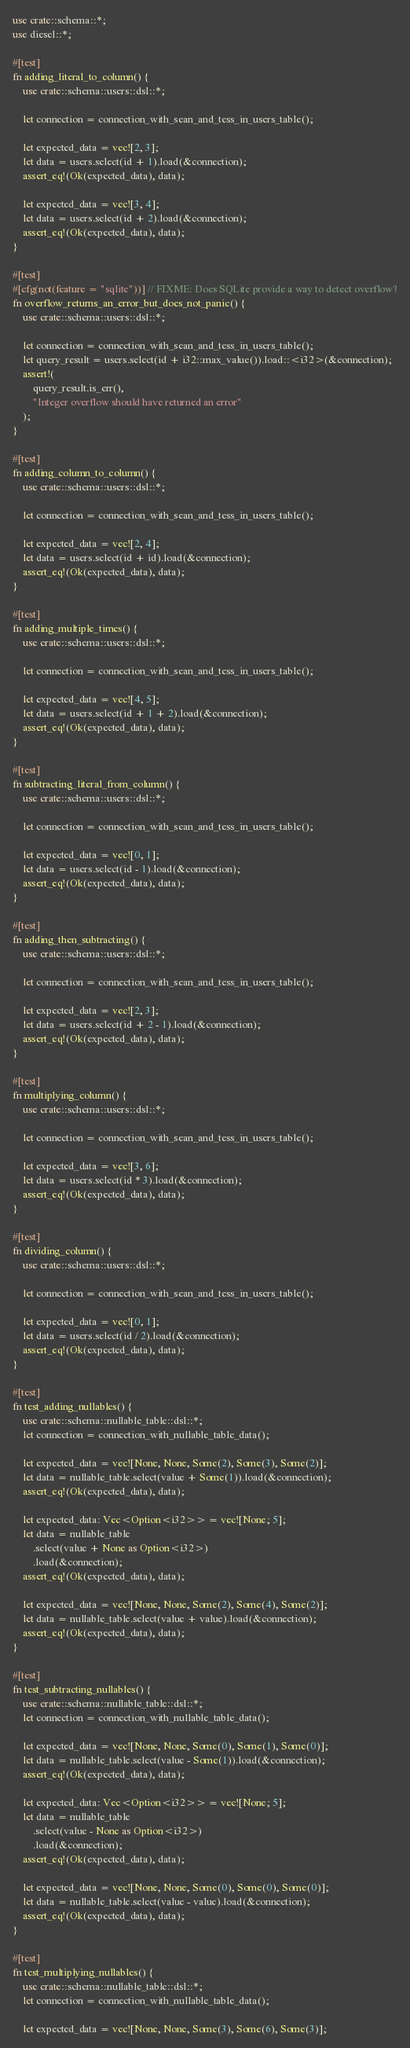<code> <loc_0><loc_0><loc_500><loc_500><_Rust_>use crate::schema::*;
use diesel::*;

#[test]
fn adding_literal_to_column() {
    use crate::schema::users::dsl::*;

    let connection = connection_with_sean_and_tess_in_users_table();

    let expected_data = vec![2, 3];
    let data = users.select(id + 1).load(&connection);
    assert_eq!(Ok(expected_data), data);

    let expected_data = vec![3, 4];
    let data = users.select(id + 2).load(&connection);
    assert_eq!(Ok(expected_data), data);
}

#[test]
#[cfg(not(feature = "sqlite"))] // FIXME: Does SQLite provide a way to detect overflow?
fn overflow_returns_an_error_but_does_not_panic() {
    use crate::schema::users::dsl::*;

    let connection = connection_with_sean_and_tess_in_users_table();
    let query_result = users.select(id + i32::max_value()).load::<i32>(&connection);
    assert!(
        query_result.is_err(),
        "Integer overflow should have returned an error"
    );
}

#[test]
fn adding_column_to_column() {
    use crate::schema::users::dsl::*;

    let connection = connection_with_sean_and_tess_in_users_table();

    let expected_data = vec![2, 4];
    let data = users.select(id + id).load(&connection);
    assert_eq!(Ok(expected_data), data);
}

#[test]
fn adding_multiple_times() {
    use crate::schema::users::dsl::*;

    let connection = connection_with_sean_and_tess_in_users_table();

    let expected_data = vec![4, 5];
    let data = users.select(id + 1 + 2).load(&connection);
    assert_eq!(Ok(expected_data), data);
}

#[test]
fn subtracting_literal_from_column() {
    use crate::schema::users::dsl::*;

    let connection = connection_with_sean_and_tess_in_users_table();

    let expected_data = vec![0, 1];
    let data = users.select(id - 1).load(&connection);
    assert_eq!(Ok(expected_data), data);
}

#[test]
fn adding_then_subtracting() {
    use crate::schema::users::dsl::*;

    let connection = connection_with_sean_and_tess_in_users_table();

    let expected_data = vec![2, 3];
    let data = users.select(id + 2 - 1).load(&connection);
    assert_eq!(Ok(expected_data), data);
}

#[test]
fn multiplying_column() {
    use crate::schema::users::dsl::*;

    let connection = connection_with_sean_and_tess_in_users_table();

    let expected_data = vec![3, 6];
    let data = users.select(id * 3).load(&connection);
    assert_eq!(Ok(expected_data), data);
}

#[test]
fn dividing_column() {
    use crate::schema::users::dsl::*;

    let connection = connection_with_sean_and_tess_in_users_table();

    let expected_data = vec![0, 1];
    let data = users.select(id / 2).load(&connection);
    assert_eq!(Ok(expected_data), data);
}

#[test]
fn test_adding_nullables() {
    use crate::schema::nullable_table::dsl::*;
    let connection = connection_with_nullable_table_data();

    let expected_data = vec![None, None, Some(2), Some(3), Some(2)];
    let data = nullable_table.select(value + Some(1)).load(&connection);
    assert_eq!(Ok(expected_data), data);

    let expected_data: Vec<Option<i32>> = vec![None; 5];
    let data = nullable_table
        .select(value + None as Option<i32>)
        .load(&connection);
    assert_eq!(Ok(expected_data), data);

    let expected_data = vec![None, None, Some(2), Some(4), Some(2)];
    let data = nullable_table.select(value + value).load(&connection);
    assert_eq!(Ok(expected_data), data);
}

#[test]
fn test_subtracting_nullables() {
    use crate::schema::nullable_table::dsl::*;
    let connection = connection_with_nullable_table_data();

    let expected_data = vec![None, None, Some(0), Some(1), Some(0)];
    let data = nullable_table.select(value - Some(1)).load(&connection);
    assert_eq!(Ok(expected_data), data);

    let expected_data: Vec<Option<i32>> = vec![None; 5];
    let data = nullable_table
        .select(value - None as Option<i32>)
        .load(&connection);
    assert_eq!(Ok(expected_data), data);

    let expected_data = vec![None, None, Some(0), Some(0), Some(0)];
    let data = nullable_table.select(value - value).load(&connection);
    assert_eq!(Ok(expected_data), data);
}

#[test]
fn test_multiplying_nullables() {
    use crate::schema::nullable_table::dsl::*;
    let connection = connection_with_nullable_table_data();

    let expected_data = vec![None, None, Some(3), Some(6), Some(3)];</code> 